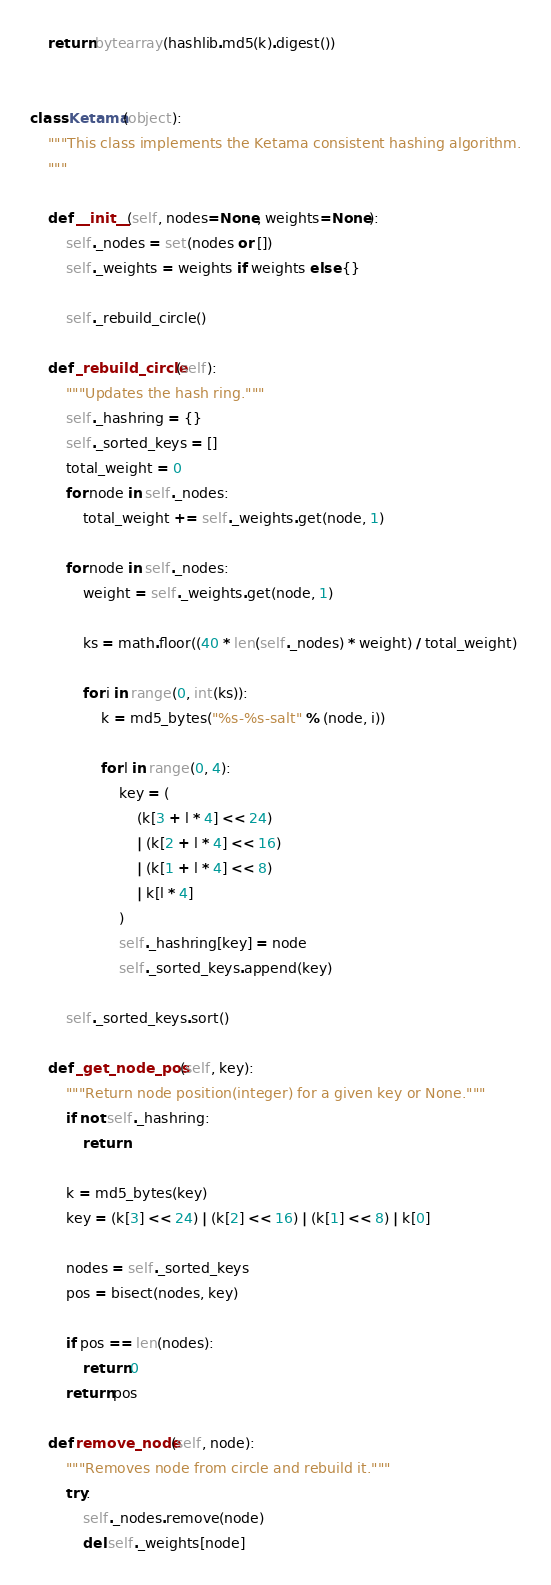<code> <loc_0><loc_0><loc_500><loc_500><_Python_>    return bytearray(hashlib.md5(k).digest())


class Ketama(object):
    """This class implements the Ketama consistent hashing algorithm.
    """

    def __init__(self, nodes=None, weights=None):
        self._nodes = set(nodes or [])
        self._weights = weights if weights else {}

        self._rebuild_circle()

    def _rebuild_circle(self):
        """Updates the hash ring."""
        self._hashring = {}
        self._sorted_keys = []
        total_weight = 0
        for node in self._nodes:
            total_weight += self._weights.get(node, 1)

        for node in self._nodes:
            weight = self._weights.get(node, 1)

            ks = math.floor((40 * len(self._nodes) * weight) / total_weight)

            for i in range(0, int(ks)):
                k = md5_bytes("%s-%s-salt" % (node, i))

                for l in range(0, 4):
                    key = (
                        (k[3 + l * 4] << 24)
                        | (k[2 + l * 4] << 16)
                        | (k[1 + l * 4] << 8)
                        | k[l * 4]
                    )
                    self._hashring[key] = node
                    self._sorted_keys.append(key)

        self._sorted_keys.sort()

    def _get_node_pos(self, key):
        """Return node position(integer) for a given key or None."""
        if not self._hashring:
            return

        k = md5_bytes(key)
        key = (k[3] << 24) | (k[2] << 16) | (k[1] << 8) | k[0]

        nodes = self._sorted_keys
        pos = bisect(nodes, key)

        if pos == len(nodes):
            return 0
        return pos

    def remove_node(self, node):
        """Removes node from circle and rebuild it."""
        try:
            self._nodes.remove(node)
            del self._weights[node]</code> 